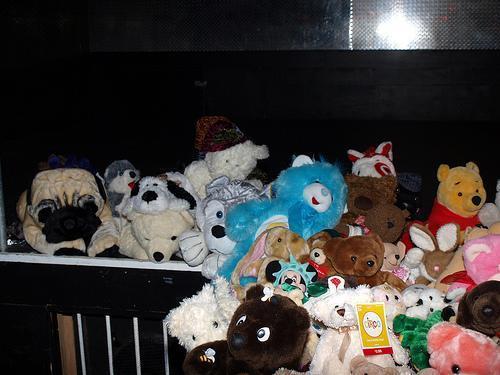How many blue bears are there?
Give a very brief answer. 1. 